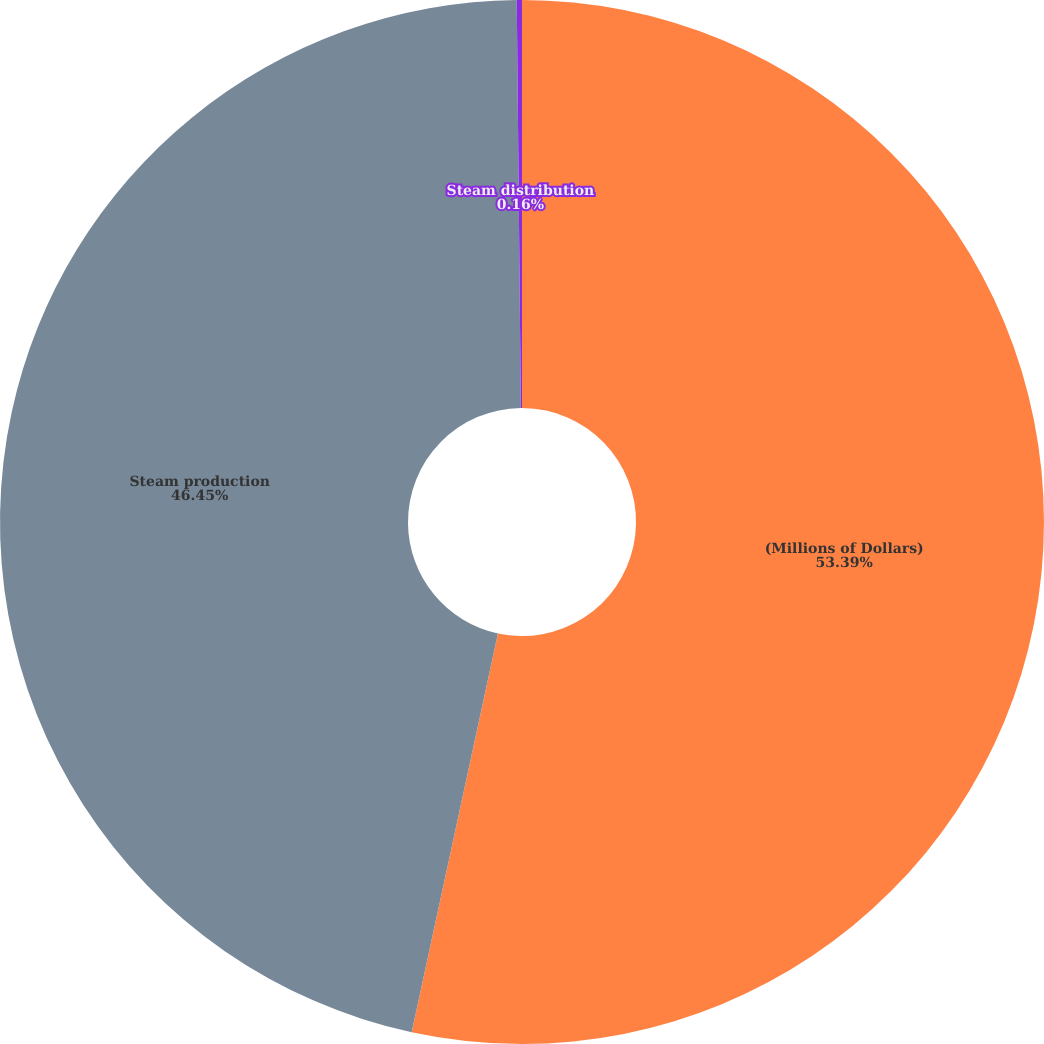Convert chart. <chart><loc_0><loc_0><loc_500><loc_500><pie_chart><fcel>(Millions of Dollars)<fcel>Steam production<fcel>Steam distribution<nl><fcel>53.39%<fcel>46.45%<fcel>0.16%<nl></chart> 